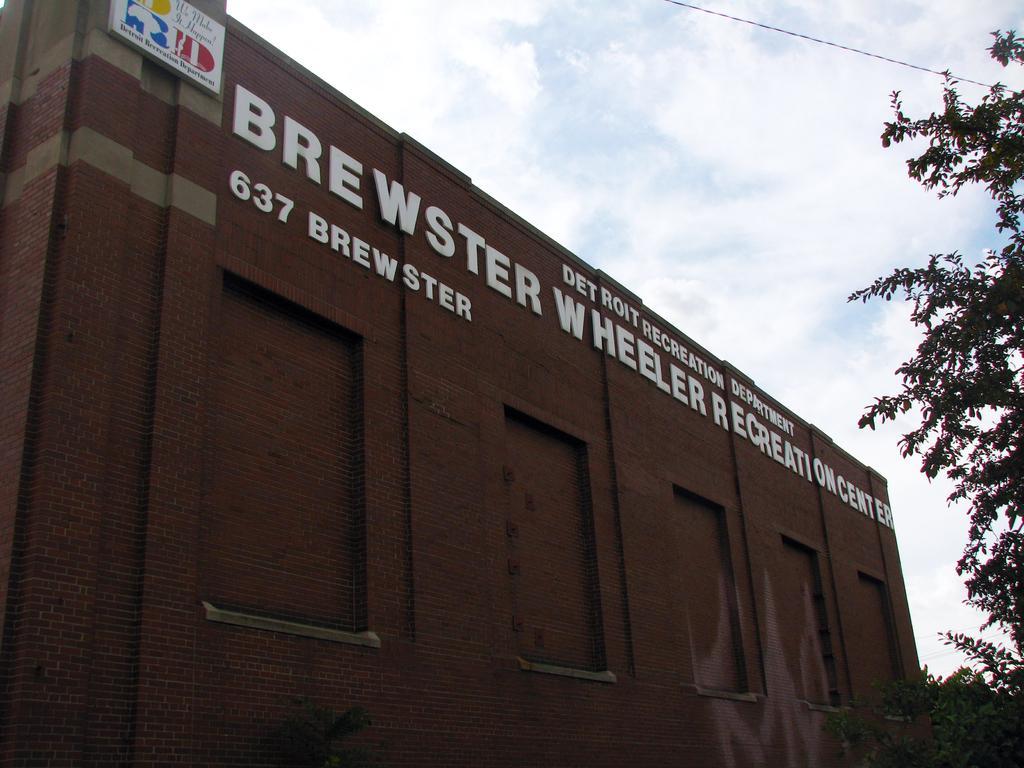How would you summarize this image in a sentence or two? In the center of the image there is a building. On the right we can see a tree. At the top there is sky and we can see a wire. 